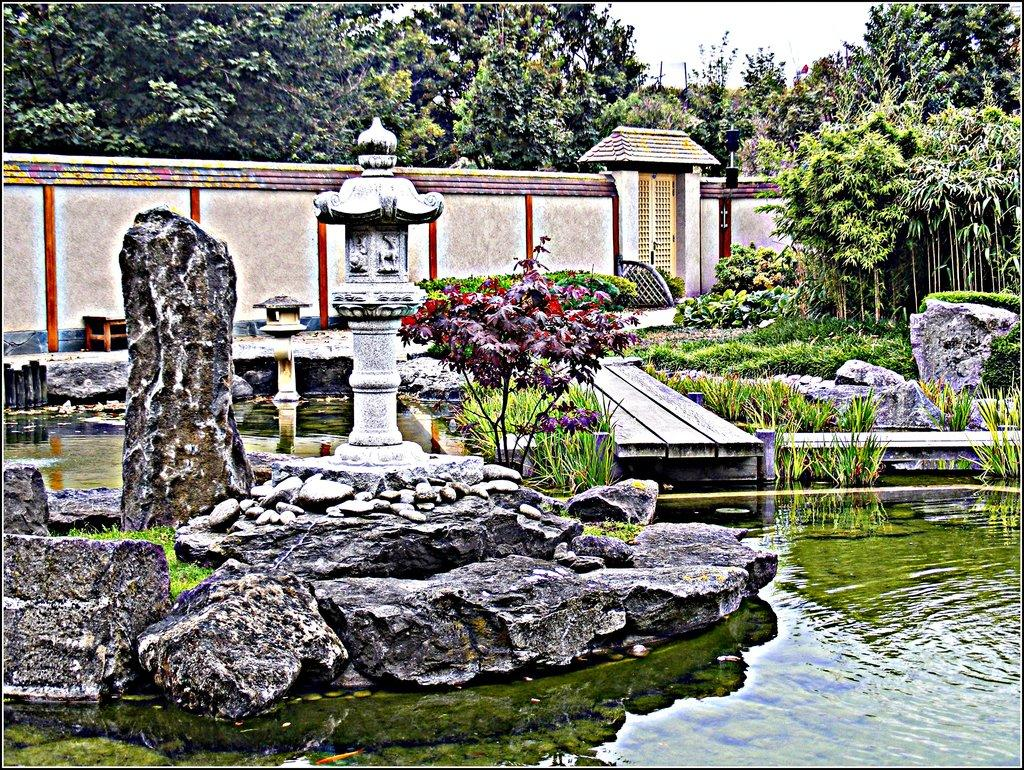What type of objects are in the image? There are stone sculptures in the image. Where are the stone sculptures located? The stone sculptures are placed in a pond. What can be seen in the background of the image? There is a wall, a door, a group of trees, and the sky visible in the background of the image. What type of voice can be heard coming from the church in the image? There is no church present in the image, so it's not possible to determine what, if any, voice might be heard. 